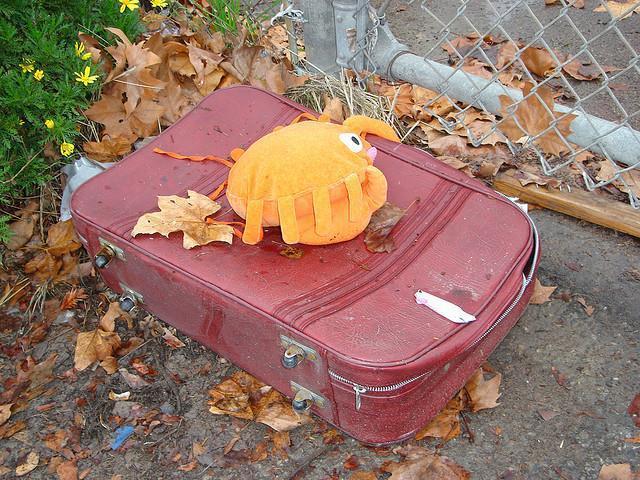How many flowers in the picture?
Give a very brief answer. 8. How many elephants are touching trunks together?
Give a very brief answer. 0. 